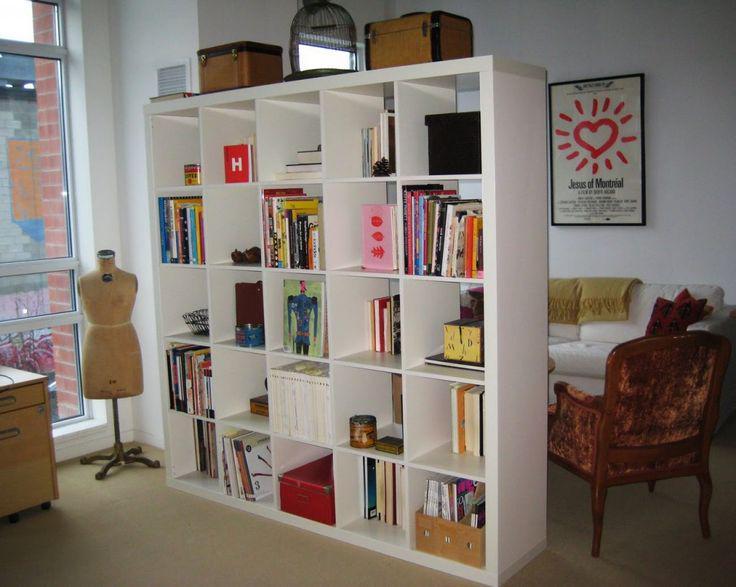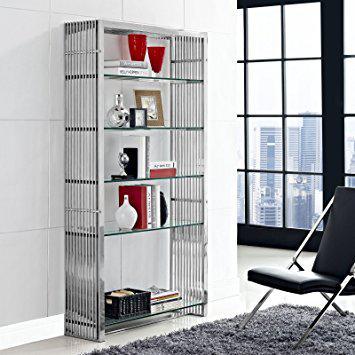The first image is the image on the left, the second image is the image on the right. Examine the images to the left and right. Is the description "In one image a large room-dividing shelf unit is placed near the foot of a bed." accurate? Answer yes or no. No. 